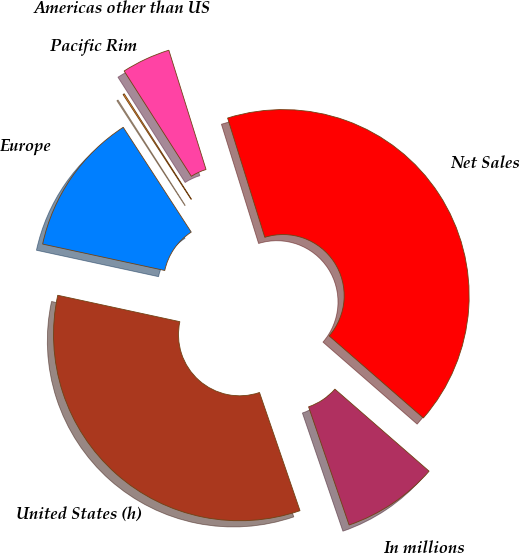<chart> <loc_0><loc_0><loc_500><loc_500><pie_chart><fcel>In millions<fcel>United States (h)<fcel>Europe<fcel>Pacific Rim<fcel>Americas other than US<fcel>Net Sales<nl><fcel>8.34%<fcel>33.65%<fcel>12.45%<fcel>0.12%<fcel>4.23%<fcel>41.22%<nl></chart> 